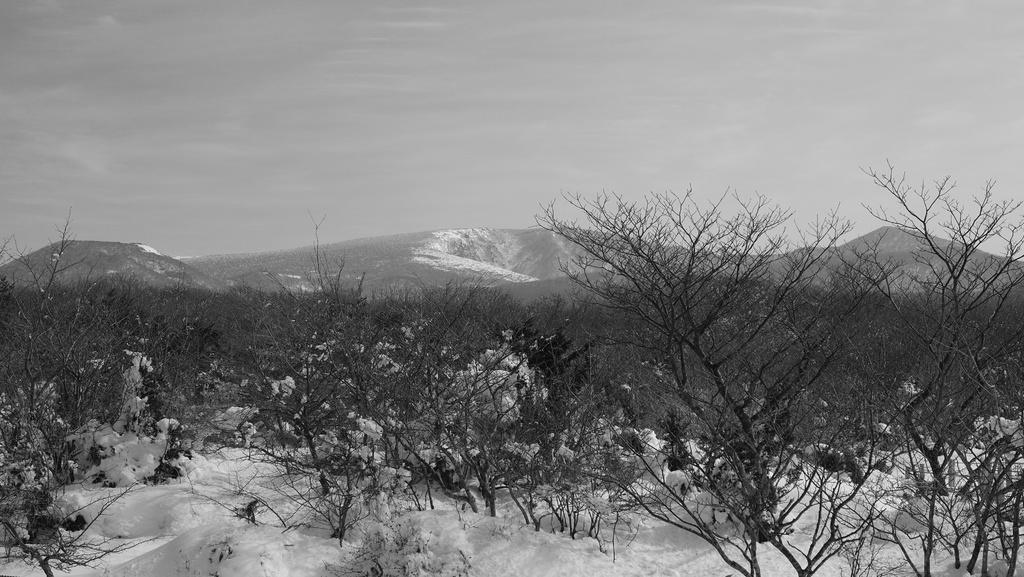What type of trees are in the image? There are dry trees in the image. What is covering the ground in the image? There is snow in the image. What type of landscape can be seen in the image? There are mountains in the image. What is the color scheme of the image? The image is in black and white color. Where is the prison located in the image? There is no prison present in the image. What type of station is visible in the image? There is no station present in the image. 